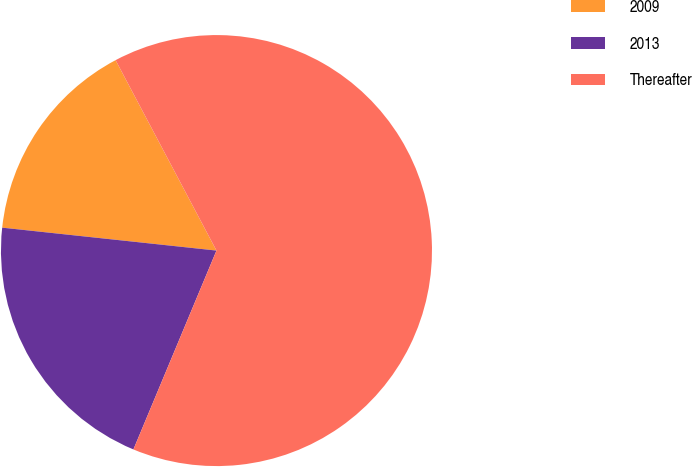Convert chart to OTSL. <chart><loc_0><loc_0><loc_500><loc_500><pie_chart><fcel>2009<fcel>2013<fcel>Thereafter<nl><fcel>15.55%<fcel>20.4%<fcel>64.05%<nl></chart> 